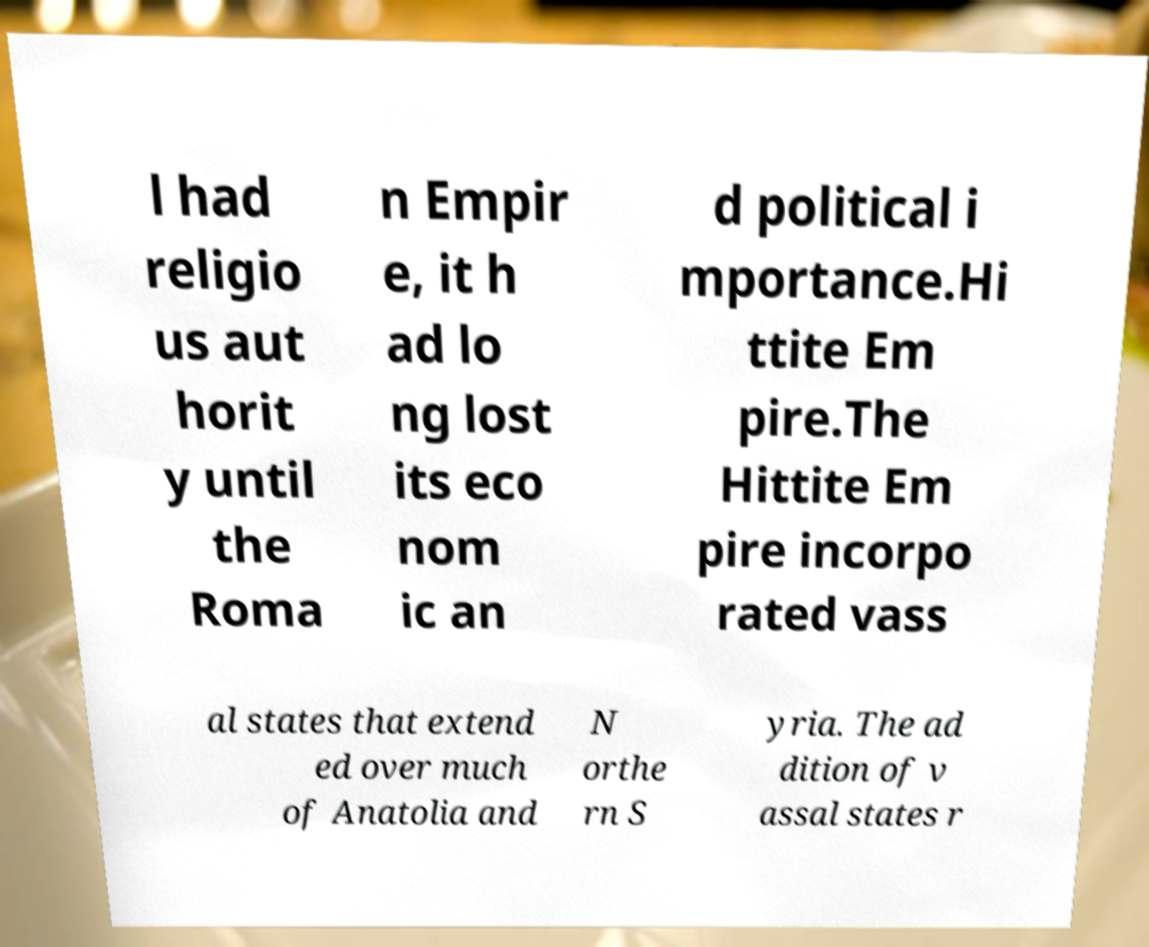Could you assist in decoding the text presented in this image and type it out clearly? l had religio us aut horit y until the Roma n Empir e, it h ad lo ng lost its eco nom ic an d political i mportance.Hi ttite Em pire.The Hittite Em pire incorpo rated vass al states that extend ed over much of Anatolia and N orthe rn S yria. The ad dition of v assal states r 